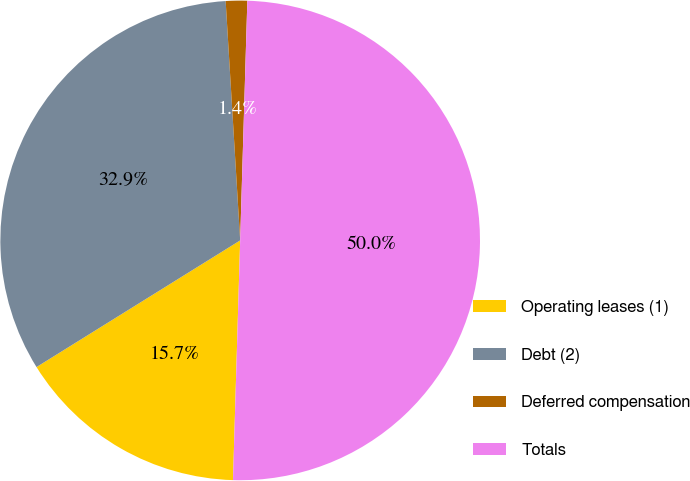Convert chart. <chart><loc_0><loc_0><loc_500><loc_500><pie_chart><fcel>Operating leases (1)<fcel>Debt (2)<fcel>Deferred compensation<fcel>Totals<nl><fcel>15.67%<fcel>32.89%<fcel>1.44%<fcel>50.0%<nl></chart> 